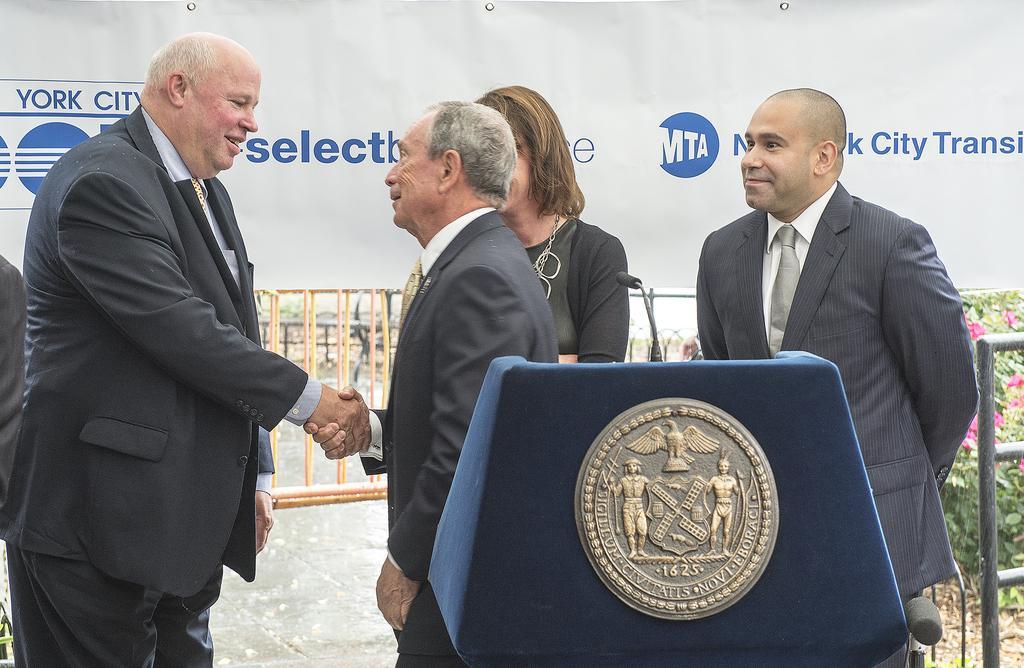How would you summarize this image in a sentence or two? In this image there are three men standing, there is a woman standing, there is a podium towards the bottom of the image, there is a microphone, there are plants towards the right of the image, there are flowers, there is a metal object towards the right of the image, there is a fence, at the top of the image there is a banner, there is text on the banner. 